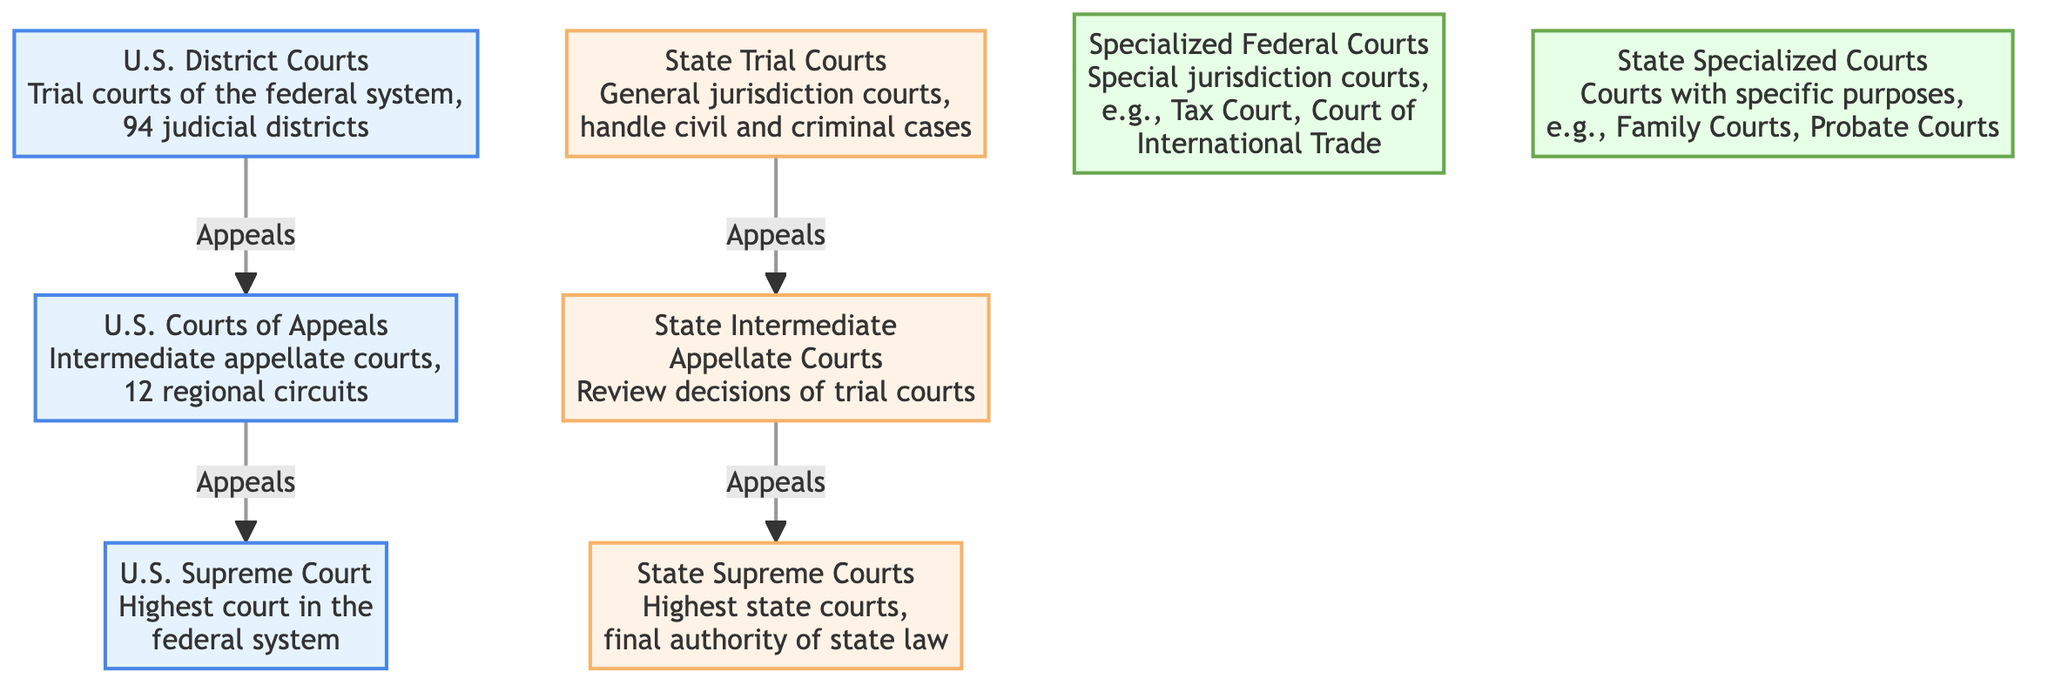What is the highest court in the federal system? The diagram indicates that the U.S. Supreme Court is the highest court in the federal system. This is directly labeled in the diagram.
Answer: U.S. Supreme Court How many regional circuits do the U.S. Courts of Appeals have? The diagram specifies that the U.S. Courts of Appeals contain 12 regional circuits. This numerical detail is directly stated in the diagram.
Answer: 12 Which court reviews decisions of trial courts at the state level? The diagram shows that the State Intermediate Appellate Courts review decisions made by State Trial Courts, indicating the role of this court in the hierarchy.
Answer: State Intermediate Appellate Courts What type of court is the Tax Court? According to the diagram, the Tax Court is a specialized federal court, which falls under the category of courts with specific jurisdictions.
Answer: Specialized Federal Courts How many judicial districts are there in the U.S. District Courts? The diagram notes that there are 94 judicial districts within the U.S. District Courts. This is explicitly mentioned as part of their description.
Answer: 94 Which court is the final authority on state law? The diagram states that State Supreme Courts serve as the final authority on state law, indicating their crucial position within the state court system.
Answer: State Supreme Courts What is the relationship between U.S. District Courts and U.S. Courts of Appeals? The diagram illustrates that U.S. District Courts are trial courts that can send appeals to the U.S. Courts of Appeals, showing a direct flow of appeals from one to the other.
Answer: Appeals How many levels of courts are there in each federal and state systems? The diagram displays three levels in the federal system (U.S. Supreme Court, U.S. Courts of Appeals, U.S. District Courts) and three levels in the state system (State Supreme Courts, State Intermediate Appellate Courts, State Trial Courts), thus answering the question of the hierarchy.
Answer: 3 Which courts handle civil and criminal cases at the state level? The diagram identifies State Trial Courts as those general jurisdiction courts that handle both civil and criminal cases, directly indicating their function.
Answer: State Trial Courts What are examples of specialized state courts included in the diagram? The diagram provides examples of state specialized courts, specifically Family Courts and Probate Courts, giving insight into their functions and specific purposes.
Answer: Family Courts, Probate Courts 